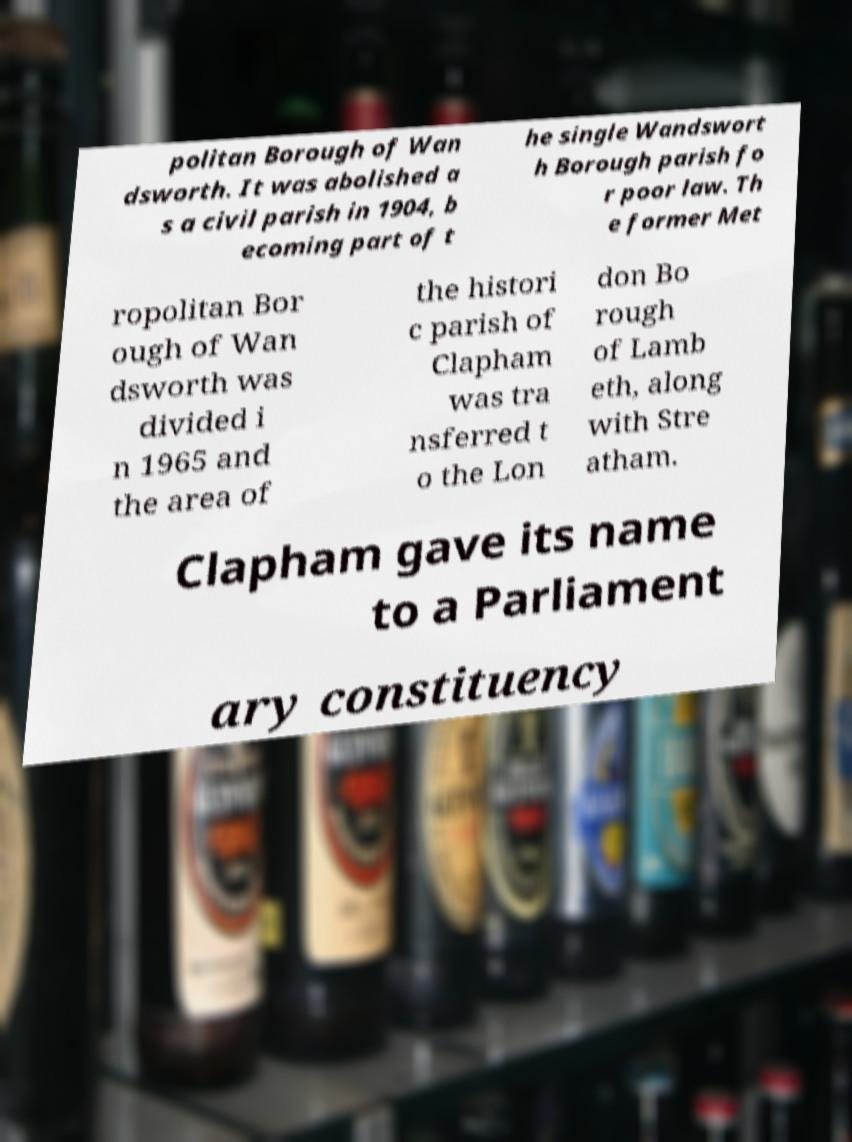Please read and relay the text visible in this image. What does it say? politan Borough of Wan dsworth. It was abolished a s a civil parish in 1904, b ecoming part of t he single Wandswort h Borough parish fo r poor law. Th e former Met ropolitan Bor ough of Wan dsworth was divided i n 1965 and the area of the histori c parish of Clapham was tra nsferred t o the Lon don Bo rough of Lamb eth, along with Stre atham. Clapham gave its name to a Parliament ary constituency 